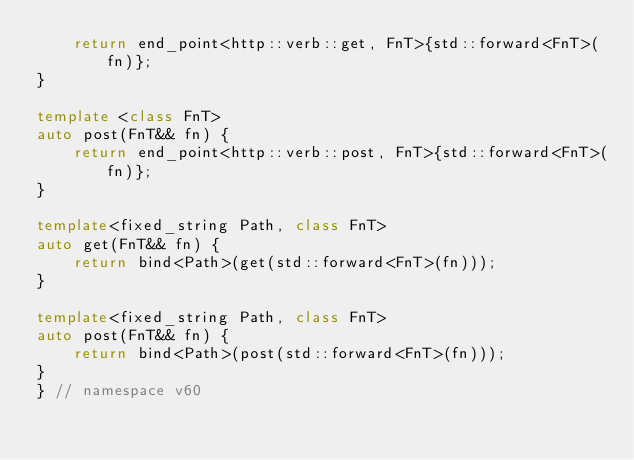<code> <loc_0><loc_0><loc_500><loc_500><_C++_>    return end_point<http::verb::get, FnT>{std::forward<FnT>(fn)};
}

template <class FnT>
auto post(FnT&& fn) {
    return end_point<http::verb::post, FnT>{std::forward<FnT>(fn)};
}

template<fixed_string Path, class FnT>
auto get(FnT&& fn) {
    return bind<Path>(get(std::forward<FnT>(fn)));
}

template<fixed_string Path, class FnT>
auto post(FnT&& fn) {
    return bind<Path>(post(std::forward<FnT>(fn)));
}
} // namespace v60</code> 